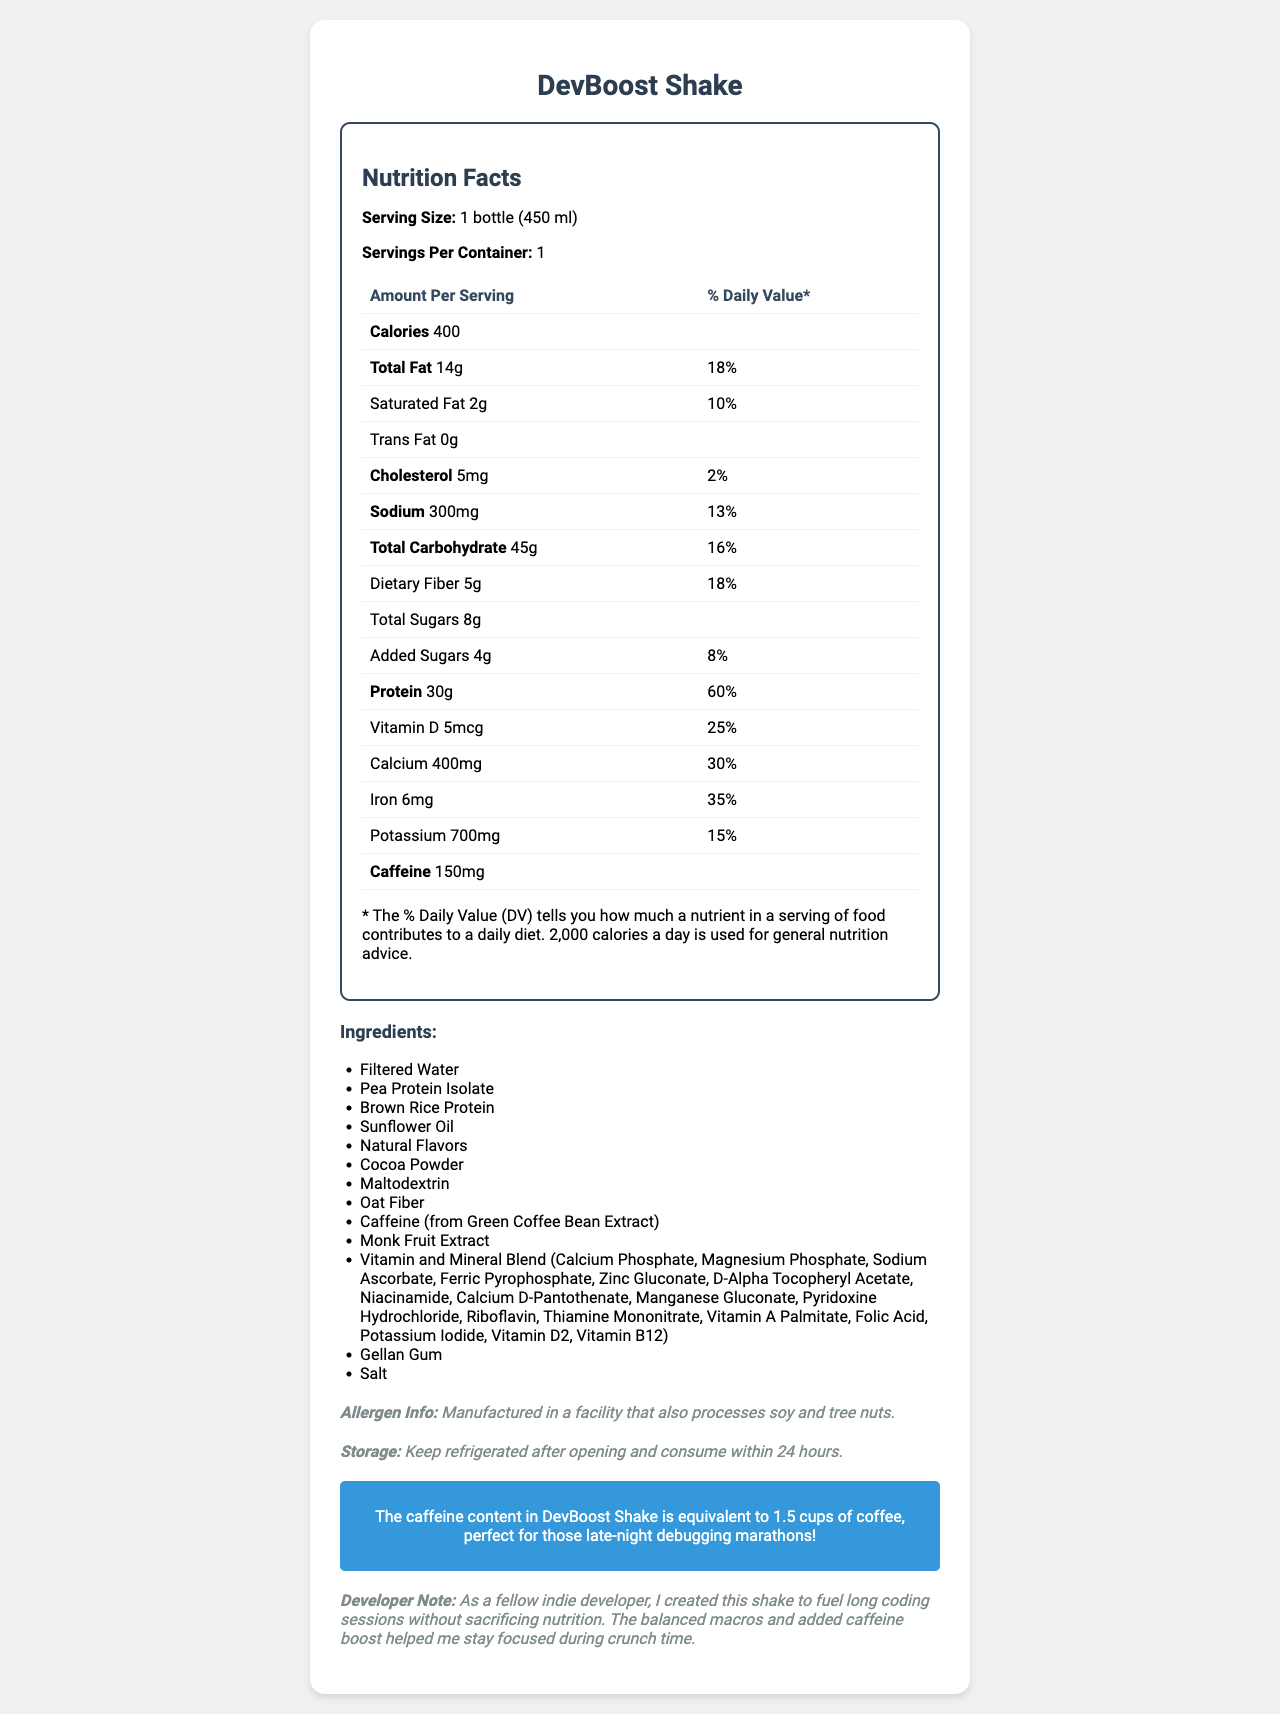how many calories are in one serving? The Nutrition Facts section states that the DevBoost Shake contains 400 calories per serving.
Answer: 400 calories what is the serving size for the DevBoost shake? The serving size is listed as 1 bottle (450 ml) in the Nutrition Facts section.
Answer: 1 bottle (450 ml) how much protein does the DevBoost Shake contain per serving? The Nutrition Facts section indicates that there are 30 grams of protein per serving.
Answer: 30g which vitamin has the highest daily value percentage in the DevBoost Shake? The Nutrition Facts section shows that protein has a daily value percentage of 60%, which is the highest among the listed nutrients.
Answer: Protein with 60% what is the caffeine content in the DevBoost Shake? The caffeine content is listed as 150mg in the Nutrition Facts section.
Answer: 150mg what percentage of the daily value for calcium does one serving of DevBoost Shake provide? The Nutrition Facts section indicates that one serving provides 30% of the daily value for calcium.
Answer: 30% how much dietary fiber is in each serving of the DevBoost Shake? A. 3g B. 5g C. 7g D. 10g The Nutrition Facts section lists dietary fiber as 5 grams per serving.
Answer: B. 5g which ingredient is listed first in the ingredients list? A. Pea Protein Isolate B. Filtered Water C. Natural Flavors D. Sunflower Oil The Ingredients section lists Filtered Water as the first ingredient.
Answer: B. Filtered Water is the DevBoost Shake suitable for someone with a tree nut allergy? The allergen information states that it is manufactured in a facility that processes soy and tree nuts.
Answer: No name two types of protein sources mentioned in the ingredients. The Ingredients section lists Pea Protein Isolate and Brown Rice Protein as two of the protein sources.
Answer: Pea Protein Isolate and Brown Rice Protein summarize the main purpose and key features of the DevBoost Shake. The document highlights the DevBoost Shake's role as a convenient and nutritious meal replacement specifically aimed at indie developers who need sustained energy and increased focus. Key features include its protein content, added vitamins and minerals, and an amount of caffeine equivalent to 1.5 cups of coffee.
Answer: The DevBoost Shake is designed as a caffeine-infused meal replacement shake for busy indie developers to fuel long coding sessions without sacrificing nutrition. It provides a balanced macro-nutrient profile with 400 calories, 30g of protein, essential vitamins and minerals, and 150mg of caffeine to enhance focus. how long should you consume DevBoost Shake after opening? The storage information states that the shake should be kept refrigerated after opening and consumed within 24 hours.
Answer: Within 24 hours what is the total fat content per serving and its daily value percentage? The Nutrition Facts section lists the total fat content as 14 grams per serving, which is 18% of the daily value.
Answer: 14g, 18% which form of vitamin A is included in the ingredients list? The Ingredients section lists Vitamin A Palmitate as the form of vitamin A included.
Answer: Vitamin A Palmitate where is the caffeine in the DevBoost Shake sourced from? The Ingredients section mentions that caffeine is sourced from Green Coffee Bean Extract.
Answer: Green Coffee Bean Extract how much sodium is in one serving of the DevBoost Shake? The Nutrition Facts section states that the sodium content is 300mg per serving.
Answer: 300mg how many servings are there in one container of the DevBoost Shake? The Nutrition Facts section states that there is 1 serving per container.
Answer: 1 serving what is the main benefit highlighted in the developer note? The developer note mentions that the balanced macros and added caffeine boost help indie developers stay focused during crunch time.
Answer: Enhanced focus during long coding sessions can the ingredients of the DevBoost Shake be altered for individual preferences? The document does not provide any details on altering the ingredients for individual preferences.
Answer: Not enough information 